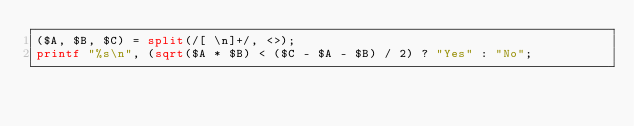Convert code to text. <code><loc_0><loc_0><loc_500><loc_500><_Perl_>($A, $B, $C) = split(/[ \n]+/, <>);
printf "%s\n", (sqrt($A * $B) < ($C - $A - $B) / 2) ? "Yes" : "No";
</code> 